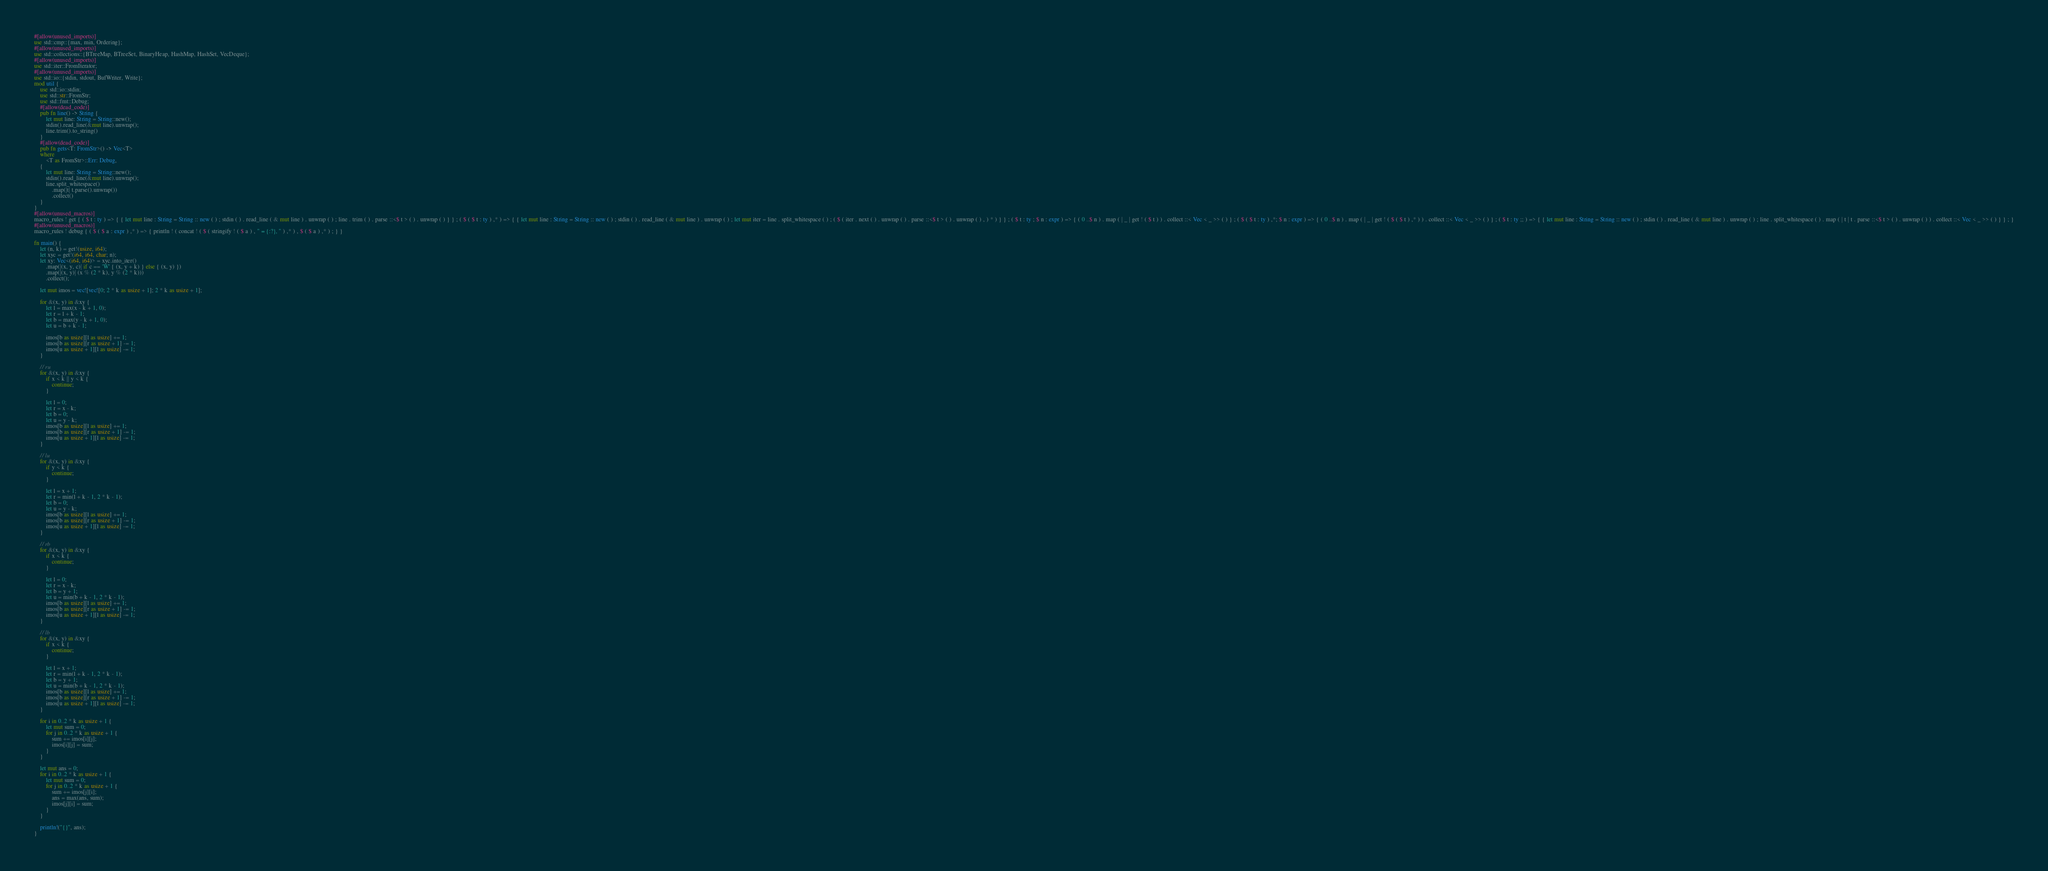Convert code to text. <code><loc_0><loc_0><loc_500><loc_500><_Rust_>#[allow(unused_imports)]
use std::cmp::{max, min, Ordering};
#[allow(unused_imports)]
use std::collections::{BTreeMap, BTreeSet, BinaryHeap, HashMap, HashSet, VecDeque};
#[allow(unused_imports)]
use std::iter::FromIterator;
#[allow(unused_imports)]
use std::io::{stdin, stdout, BufWriter, Write};
mod util {
    use std::io::stdin;
    use std::str::FromStr;
    use std::fmt::Debug;
    #[allow(dead_code)]
    pub fn line() -> String {
        let mut line: String = String::new();
        stdin().read_line(&mut line).unwrap();
        line.trim().to_string()
    }
    #[allow(dead_code)]
    pub fn gets<T: FromStr>() -> Vec<T>
    where
        <T as FromStr>::Err: Debug,
    {
        let mut line: String = String::new();
        stdin().read_line(&mut line).unwrap();
        line.split_whitespace()
            .map(|t| t.parse().unwrap())
            .collect()
    }
}
#[allow(unused_macros)]
macro_rules ! get { ( $ t : ty ) => { { let mut line : String = String :: new ( ) ; stdin ( ) . read_line ( & mut line ) . unwrap ( ) ; line . trim ( ) . parse ::<$ t > ( ) . unwrap ( ) } } ; ( $ ( $ t : ty ) ,* ) => { { let mut line : String = String :: new ( ) ; stdin ( ) . read_line ( & mut line ) . unwrap ( ) ; let mut iter = line . split_whitespace ( ) ; ( $ ( iter . next ( ) . unwrap ( ) . parse ::<$ t > ( ) . unwrap ( ) , ) * ) } } ; ( $ t : ty ; $ n : expr ) => { ( 0 ..$ n ) . map ( | _ | get ! ( $ t ) ) . collect ::< Vec < _ >> ( ) } ; ( $ ( $ t : ty ) ,*; $ n : expr ) => { ( 0 ..$ n ) . map ( | _ | get ! ( $ ( $ t ) ,* ) ) . collect ::< Vec < _ >> ( ) } ; ( $ t : ty ;; ) => { { let mut line : String = String :: new ( ) ; stdin ( ) . read_line ( & mut line ) . unwrap ( ) ; line . split_whitespace ( ) . map ( | t | t . parse ::<$ t > ( ) . unwrap ( ) ) . collect ::< Vec < _ >> ( ) } } ; }
#[allow(unused_macros)]
macro_rules ! debug { ( $ ( $ a : expr ) ,* ) => { println ! ( concat ! ( $ ( stringify ! ( $ a ) , " = {:?}, " ) ,* ) , $ ( $ a ) ,* ) ; } }

fn main() {
    let (n, k) = get!(usize, i64);
    let xyc = get!(i64, i64, char; n);
    let xy: Vec<(i64, i64)> = xyc.into_iter()
        .map(|(x, y, c)| if c == 'W' { (x, y + k) } else { (x, y) })
        .map(|(x, y)| (x % (2 * k), y % (2 * k)))
        .collect();

    let mut imos = vec![vec![0; 2 * k as usize + 1]; 2 * k as usize + 1];

    for &(x, y) in &xy {
        let l = max(x - k + 1, 0);
        let r = l + k - 1;
        let b = max(y - k + 1, 0);
        let u = b + k - 1;

        imos[b as usize][l as usize] += 1;
        imos[b as usize][r as usize + 1] -= 1;
        imos[u as usize + 1][l as usize] -= 1;
    }

    // ru
    for &(x, y) in &xy {
        if x < k || y < k {
            continue;
        }

        let l = 0;
        let r = x - k;
        let b = 0;
        let u = y - k;
        imos[b as usize][l as usize] += 1;
        imos[b as usize][r as usize + 1] -= 1;
        imos[u as usize + 1][l as usize] -= 1;
    }

    // lu
    for &(x, y) in &xy {
        if y < k {
            continue;
        }

        let l = x + 1;
        let r = min(l + k - 1, 2 * k - 1);
        let b = 0;
        let u = y - k;
        imos[b as usize][l as usize] += 1;
        imos[b as usize][r as usize + 1] -= 1;
        imos[u as usize + 1][l as usize] -= 1;
    }

    // rb
    for &(x, y) in &xy {
        if x < k {
            continue;
        }

        let l = 0;
        let r = x - k;
        let b = y + 1;
        let u = min(b + k - 1, 2 * k - 1);
        imos[b as usize][l as usize] += 1;
        imos[b as usize][r as usize + 1] -= 1;
        imos[u as usize + 1][l as usize] -= 1;
    }

    // lb
    for &(x, y) in &xy {
        if x < k {
            continue;
        }

        let l = x + 1;
        let r = min(l + k - 1, 2 * k - 1);
        let b = y + 1;
        let u = min(b + k - 1, 2 * k - 1);
        imos[b as usize][l as usize] += 1;
        imos[b as usize][r as usize + 1] -= 1;
        imos[u as usize + 1][l as usize] -= 1;
    }

    for i in 0..2 * k as usize + 1 {
        let mut sum = 0;
        for j in 0..2 * k as usize + 1 {
            sum += imos[i][j];
            imos[i][j] = sum;
        }
    }

    let mut ans = 0;
    for i in 0..2 * k as usize + 1 {
        let mut sum = 0;
        for j in 0..2 * k as usize + 1 {
            sum += imos[j][i];
            ans = max(ans, sum);
            imos[j][i] = sum;
        }
    }

    println!("{}", ans);
}
</code> 